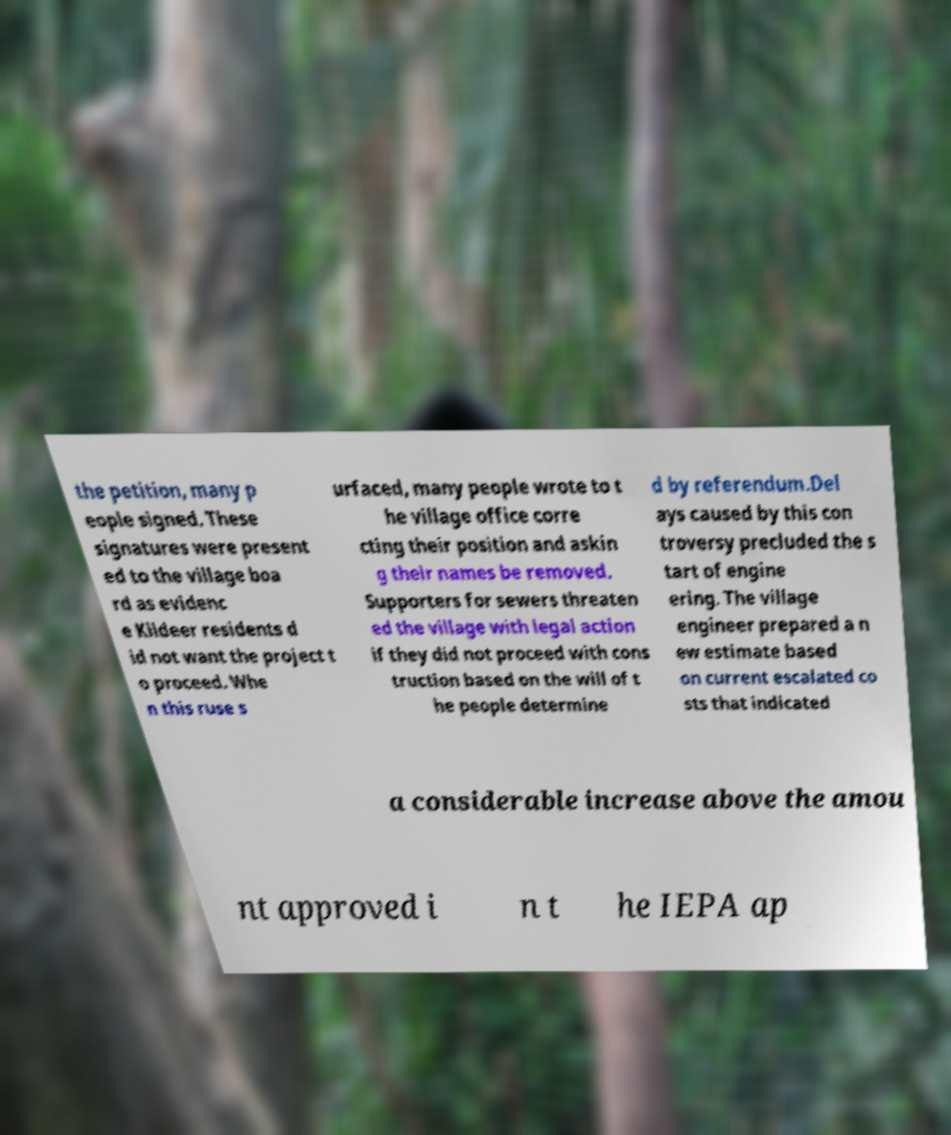For documentation purposes, I need the text within this image transcribed. Could you provide that? the petition, many p eople signed. These signatures were present ed to the village boa rd as evidenc e Kildeer residents d id not want the project t o proceed. Whe n this ruse s urfaced, many people wrote to t he village office corre cting their position and askin g their names be removed. Supporters for sewers threaten ed the village with legal action if they did not proceed with cons truction based on the will of t he people determine d by referendum.Del ays caused by this con troversy precluded the s tart of engine ering. The village engineer prepared a n ew estimate based on current escalated co sts that indicated a considerable increase above the amou nt approved i n t he IEPA ap 